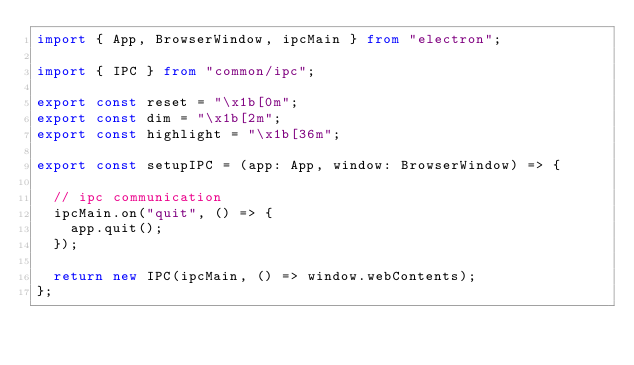<code> <loc_0><loc_0><loc_500><loc_500><_TypeScript_>import { App, BrowserWindow, ipcMain } from "electron";

import { IPC } from "common/ipc";

export const reset = "\x1b[0m";
export const dim = "\x1b[2m";
export const highlight = "\x1b[36m";

export const setupIPC = (app: App, window: BrowserWindow) => {

  // ipc communication
  ipcMain.on("quit", () => {
    app.quit();
  });

  return new IPC(ipcMain, () => window.webContents);
};
</code> 